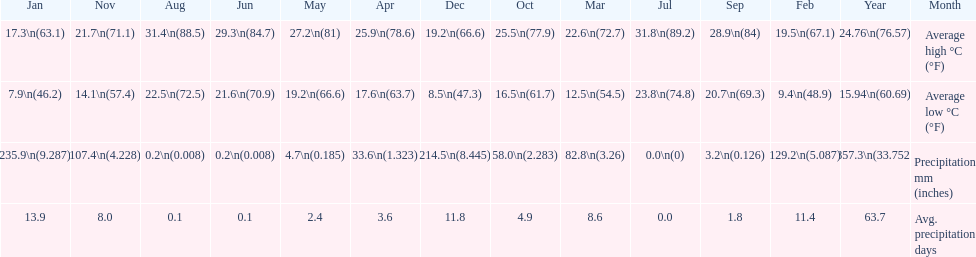Would you be able to parse every entry in this table? {'header': ['Jan', 'Nov', 'Aug', 'Jun', 'May', 'Apr', 'Dec', 'Oct', 'Mar', 'Jul', 'Sep', 'Feb', 'Year', 'Month'], 'rows': [['17.3\\n(63.1)', '21.7\\n(71.1)', '31.4\\n(88.5)', '29.3\\n(84.7)', '27.2\\n(81)', '25.9\\n(78.6)', '19.2\\n(66.6)', '25.5\\n(77.9)', '22.6\\n(72.7)', '31.8\\n(89.2)', '28.9\\n(84)', '19.5\\n(67.1)', '24.76\\n(76.57)', 'Average high °C (°F)'], ['7.9\\n(46.2)', '14.1\\n(57.4)', '22.5\\n(72.5)', '21.6\\n(70.9)', '19.2\\n(66.6)', '17.6\\n(63.7)', '8.5\\n(47.3)', '16.5\\n(61.7)', '12.5\\n(54.5)', '23.8\\n(74.8)', '20.7\\n(69.3)', '9.4\\n(48.9)', '15.94\\n(60.69)', 'Average low °C (°F)'], ['235.9\\n(9.287)', '107.4\\n(4.228)', '0.2\\n(0.008)', '0.2\\n(0.008)', '4.7\\n(0.185)', '33.6\\n(1.323)', '214.5\\n(8.445)', '58.0\\n(2.283)', '82.8\\n(3.26)', '0.0\\n(0)', '3.2\\n(0.126)', '129.2\\n(5.087)', '857.3\\n(33.752)', 'Precipitation mm (inches)'], ['13.9', '8.0', '0.1', '0.1', '2.4', '3.6', '11.8', '4.9', '8.6', '0.0', '1.8', '11.4', '63.7', 'Avg. precipitation days']]} What is the month with the lowest average low in haifa? January. 